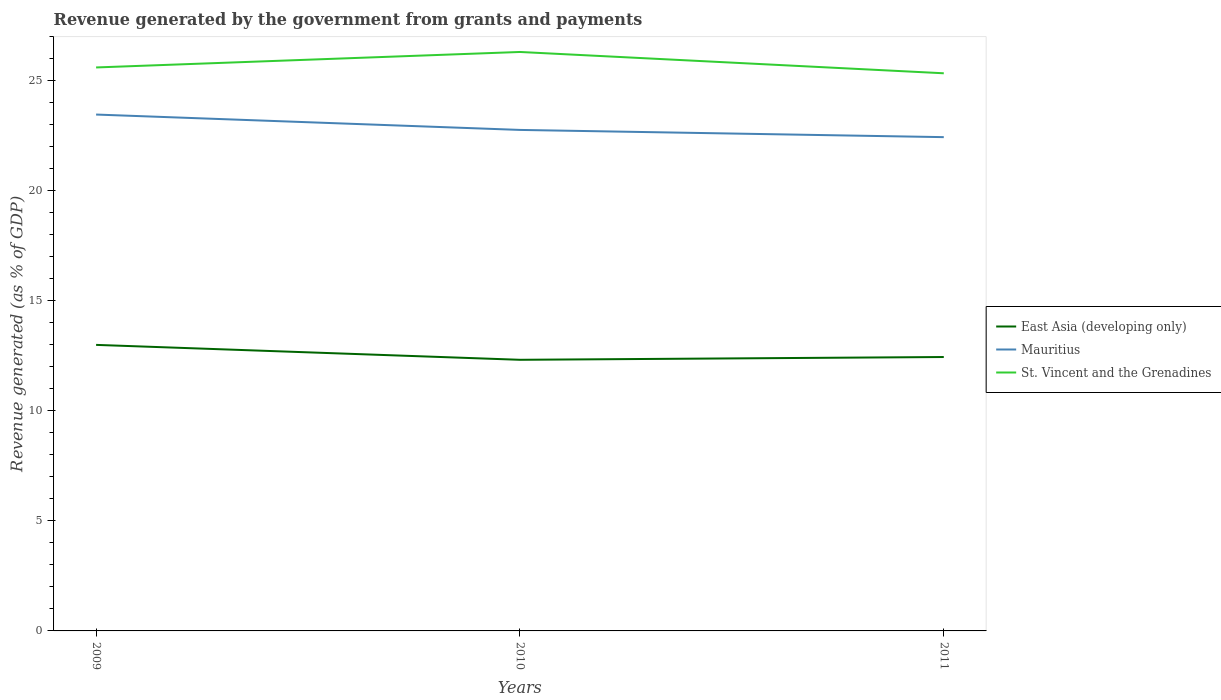Is the number of lines equal to the number of legend labels?
Offer a very short reply. Yes. Across all years, what is the maximum revenue generated by the government in St. Vincent and the Grenadines?
Offer a very short reply. 25.33. What is the total revenue generated by the government in East Asia (developing only) in the graph?
Ensure brevity in your answer.  -0.13. What is the difference between the highest and the second highest revenue generated by the government in St. Vincent and the Grenadines?
Ensure brevity in your answer.  0.97. What is the difference between the highest and the lowest revenue generated by the government in East Asia (developing only)?
Keep it short and to the point. 1. Is the revenue generated by the government in East Asia (developing only) strictly greater than the revenue generated by the government in Mauritius over the years?
Your answer should be very brief. Yes. Does the graph contain any zero values?
Provide a short and direct response. No. What is the title of the graph?
Keep it short and to the point. Revenue generated by the government from grants and payments. What is the label or title of the Y-axis?
Provide a succinct answer. Revenue generated (as % of GDP). What is the Revenue generated (as % of GDP) in East Asia (developing only) in 2009?
Provide a succinct answer. 13. What is the Revenue generated (as % of GDP) of Mauritius in 2009?
Your answer should be compact. 23.46. What is the Revenue generated (as % of GDP) of St. Vincent and the Grenadines in 2009?
Your answer should be very brief. 25.6. What is the Revenue generated (as % of GDP) in East Asia (developing only) in 2010?
Keep it short and to the point. 12.32. What is the Revenue generated (as % of GDP) of Mauritius in 2010?
Make the answer very short. 22.76. What is the Revenue generated (as % of GDP) in St. Vincent and the Grenadines in 2010?
Offer a terse response. 26.3. What is the Revenue generated (as % of GDP) in East Asia (developing only) in 2011?
Keep it short and to the point. 12.44. What is the Revenue generated (as % of GDP) in Mauritius in 2011?
Your answer should be compact. 22.43. What is the Revenue generated (as % of GDP) in St. Vincent and the Grenadines in 2011?
Give a very brief answer. 25.33. Across all years, what is the maximum Revenue generated (as % of GDP) in East Asia (developing only)?
Keep it short and to the point. 13. Across all years, what is the maximum Revenue generated (as % of GDP) of Mauritius?
Keep it short and to the point. 23.46. Across all years, what is the maximum Revenue generated (as % of GDP) in St. Vincent and the Grenadines?
Ensure brevity in your answer.  26.3. Across all years, what is the minimum Revenue generated (as % of GDP) of East Asia (developing only)?
Your answer should be very brief. 12.32. Across all years, what is the minimum Revenue generated (as % of GDP) of Mauritius?
Your answer should be compact. 22.43. Across all years, what is the minimum Revenue generated (as % of GDP) of St. Vincent and the Grenadines?
Ensure brevity in your answer.  25.33. What is the total Revenue generated (as % of GDP) in East Asia (developing only) in the graph?
Give a very brief answer. 37.76. What is the total Revenue generated (as % of GDP) of Mauritius in the graph?
Your answer should be compact. 68.66. What is the total Revenue generated (as % of GDP) of St. Vincent and the Grenadines in the graph?
Offer a very short reply. 77.24. What is the difference between the Revenue generated (as % of GDP) of East Asia (developing only) in 2009 and that in 2010?
Your answer should be compact. 0.68. What is the difference between the Revenue generated (as % of GDP) in Mauritius in 2009 and that in 2010?
Your response must be concise. 0.7. What is the difference between the Revenue generated (as % of GDP) in St. Vincent and the Grenadines in 2009 and that in 2010?
Keep it short and to the point. -0.7. What is the difference between the Revenue generated (as % of GDP) in East Asia (developing only) in 2009 and that in 2011?
Provide a short and direct response. 0.55. What is the difference between the Revenue generated (as % of GDP) of Mauritius in 2009 and that in 2011?
Make the answer very short. 1.03. What is the difference between the Revenue generated (as % of GDP) of St. Vincent and the Grenadines in 2009 and that in 2011?
Your response must be concise. 0.26. What is the difference between the Revenue generated (as % of GDP) of East Asia (developing only) in 2010 and that in 2011?
Offer a very short reply. -0.13. What is the difference between the Revenue generated (as % of GDP) of Mauritius in 2010 and that in 2011?
Offer a very short reply. 0.33. What is the difference between the Revenue generated (as % of GDP) of St. Vincent and the Grenadines in 2010 and that in 2011?
Ensure brevity in your answer.  0.97. What is the difference between the Revenue generated (as % of GDP) in East Asia (developing only) in 2009 and the Revenue generated (as % of GDP) in Mauritius in 2010?
Provide a short and direct response. -9.77. What is the difference between the Revenue generated (as % of GDP) of East Asia (developing only) in 2009 and the Revenue generated (as % of GDP) of St. Vincent and the Grenadines in 2010?
Provide a short and direct response. -13.31. What is the difference between the Revenue generated (as % of GDP) in Mauritius in 2009 and the Revenue generated (as % of GDP) in St. Vincent and the Grenadines in 2010?
Your answer should be very brief. -2.84. What is the difference between the Revenue generated (as % of GDP) in East Asia (developing only) in 2009 and the Revenue generated (as % of GDP) in Mauritius in 2011?
Keep it short and to the point. -9.44. What is the difference between the Revenue generated (as % of GDP) of East Asia (developing only) in 2009 and the Revenue generated (as % of GDP) of St. Vincent and the Grenadines in 2011?
Provide a succinct answer. -12.34. What is the difference between the Revenue generated (as % of GDP) of Mauritius in 2009 and the Revenue generated (as % of GDP) of St. Vincent and the Grenadines in 2011?
Ensure brevity in your answer.  -1.87. What is the difference between the Revenue generated (as % of GDP) of East Asia (developing only) in 2010 and the Revenue generated (as % of GDP) of Mauritius in 2011?
Your answer should be compact. -10.12. What is the difference between the Revenue generated (as % of GDP) in East Asia (developing only) in 2010 and the Revenue generated (as % of GDP) in St. Vincent and the Grenadines in 2011?
Offer a very short reply. -13.02. What is the difference between the Revenue generated (as % of GDP) of Mauritius in 2010 and the Revenue generated (as % of GDP) of St. Vincent and the Grenadines in 2011?
Offer a very short reply. -2.57. What is the average Revenue generated (as % of GDP) in East Asia (developing only) per year?
Your response must be concise. 12.59. What is the average Revenue generated (as % of GDP) in Mauritius per year?
Provide a short and direct response. 22.89. What is the average Revenue generated (as % of GDP) in St. Vincent and the Grenadines per year?
Ensure brevity in your answer.  25.75. In the year 2009, what is the difference between the Revenue generated (as % of GDP) of East Asia (developing only) and Revenue generated (as % of GDP) of Mauritius?
Ensure brevity in your answer.  -10.46. In the year 2009, what is the difference between the Revenue generated (as % of GDP) in East Asia (developing only) and Revenue generated (as % of GDP) in St. Vincent and the Grenadines?
Your response must be concise. -12.6. In the year 2009, what is the difference between the Revenue generated (as % of GDP) of Mauritius and Revenue generated (as % of GDP) of St. Vincent and the Grenadines?
Make the answer very short. -2.14. In the year 2010, what is the difference between the Revenue generated (as % of GDP) in East Asia (developing only) and Revenue generated (as % of GDP) in Mauritius?
Offer a terse response. -10.44. In the year 2010, what is the difference between the Revenue generated (as % of GDP) in East Asia (developing only) and Revenue generated (as % of GDP) in St. Vincent and the Grenadines?
Keep it short and to the point. -13.99. In the year 2010, what is the difference between the Revenue generated (as % of GDP) of Mauritius and Revenue generated (as % of GDP) of St. Vincent and the Grenadines?
Make the answer very short. -3.54. In the year 2011, what is the difference between the Revenue generated (as % of GDP) in East Asia (developing only) and Revenue generated (as % of GDP) in Mauritius?
Make the answer very short. -9.99. In the year 2011, what is the difference between the Revenue generated (as % of GDP) in East Asia (developing only) and Revenue generated (as % of GDP) in St. Vincent and the Grenadines?
Provide a succinct answer. -12.89. In the year 2011, what is the difference between the Revenue generated (as % of GDP) in Mauritius and Revenue generated (as % of GDP) in St. Vincent and the Grenadines?
Your response must be concise. -2.9. What is the ratio of the Revenue generated (as % of GDP) of East Asia (developing only) in 2009 to that in 2010?
Your answer should be compact. 1.05. What is the ratio of the Revenue generated (as % of GDP) of Mauritius in 2009 to that in 2010?
Keep it short and to the point. 1.03. What is the ratio of the Revenue generated (as % of GDP) in St. Vincent and the Grenadines in 2009 to that in 2010?
Offer a terse response. 0.97. What is the ratio of the Revenue generated (as % of GDP) in East Asia (developing only) in 2009 to that in 2011?
Give a very brief answer. 1.04. What is the ratio of the Revenue generated (as % of GDP) in Mauritius in 2009 to that in 2011?
Your answer should be very brief. 1.05. What is the ratio of the Revenue generated (as % of GDP) in St. Vincent and the Grenadines in 2009 to that in 2011?
Provide a short and direct response. 1.01. What is the ratio of the Revenue generated (as % of GDP) of Mauritius in 2010 to that in 2011?
Your response must be concise. 1.01. What is the ratio of the Revenue generated (as % of GDP) in St. Vincent and the Grenadines in 2010 to that in 2011?
Keep it short and to the point. 1.04. What is the difference between the highest and the second highest Revenue generated (as % of GDP) of East Asia (developing only)?
Keep it short and to the point. 0.55. What is the difference between the highest and the second highest Revenue generated (as % of GDP) of Mauritius?
Ensure brevity in your answer.  0.7. What is the difference between the highest and the second highest Revenue generated (as % of GDP) of St. Vincent and the Grenadines?
Your answer should be compact. 0.7. What is the difference between the highest and the lowest Revenue generated (as % of GDP) of East Asia (developing only)?
Provide a succinct answer. 0.68. What is the difference between the highest and the lowest Revenue generated (as % of GDP) of Mauritius?
Offer a terse response. 1.03. What is the difference between the highest and the lowest Revenue generated (as % of GDP) of St. Vincent and the Grenadines?
Provide a short and direct response. 0.97. 